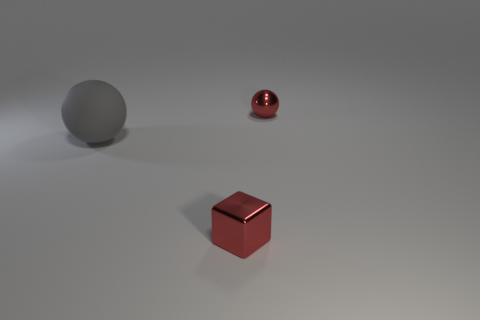How many objects are either small objects in front of the large rubber thing or small red metal objects in front of the large gray sphere? In the image, there are two small objects in question. One is a small red metal cube, and the other is a small red metal sphere. Both of these objects are situated in front of a larger gray sphere. Thus, the number of objects that fit the criteria given in your question is two. 